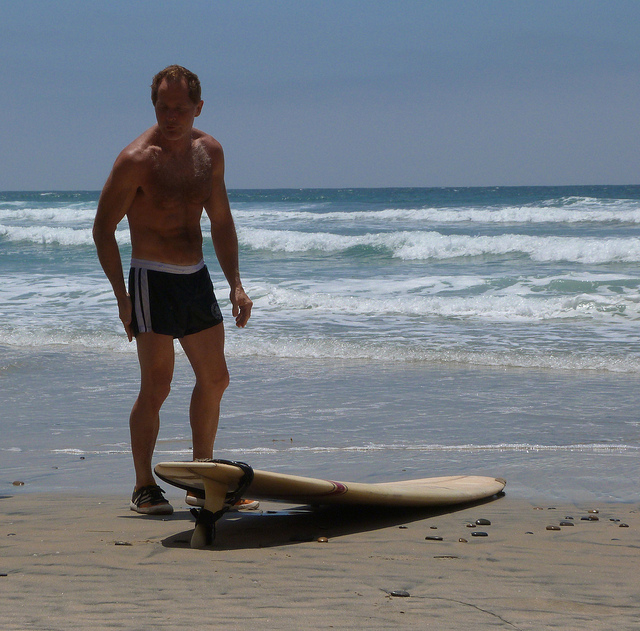Imagine the man in the image has met an alien. Describe their interaction. Just as Jack was about to pick up his surfboard, a strange, otherworldly glow appeared on the beach. Out of the light stepped a figure unlike anything he'd seen before, with luminescent skin and eyes that shimmered like the stars. The alien extended a hand, and, after a moment's hesitation, Jack reached out to shake it. Through telepathic waves, the alien communicated its curiosity about Jack's surfing. Jack, in turn, offered a lesson, showing the alien how to balance on the board. Before long, the alien was riding the waves with an ease that left Jack awestruck, proving that the passion for surfing transcends even interstellar boundaries. 